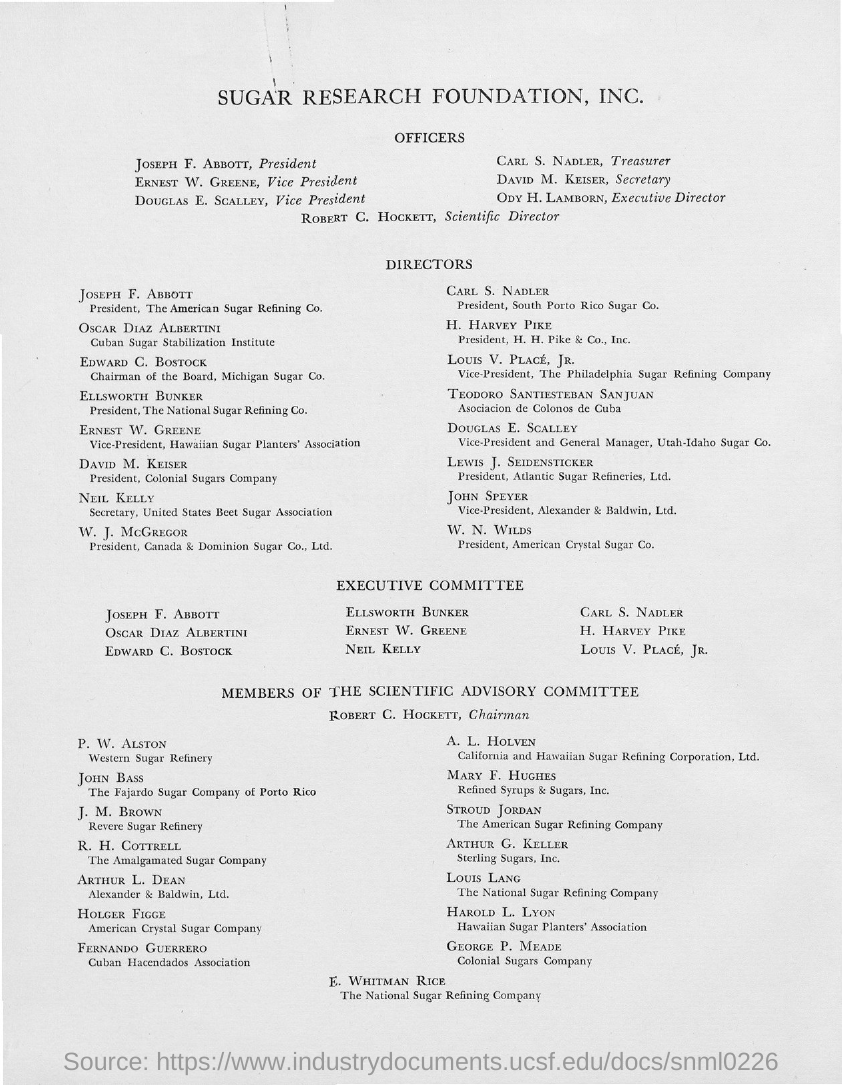What is the position of joseph f. abbott?
Your answer should be compact. President. What is the position of ernest w. greene ?
Your answer should be compact. Vice President. What is the position of douglas e. scalley ?
Keep it short and to the point. Vice President. What is the position of carl s. nadler ?
Offer a very short reply. Treasurer. What is the position of david m. keiser?
Your answer should be very brief. Secretary. What is the position of ody h. lamborn?
Offer a terse response. Executive Director. What is the position of robert c. hockett ?
Make the answer very short. Scientific Director. 